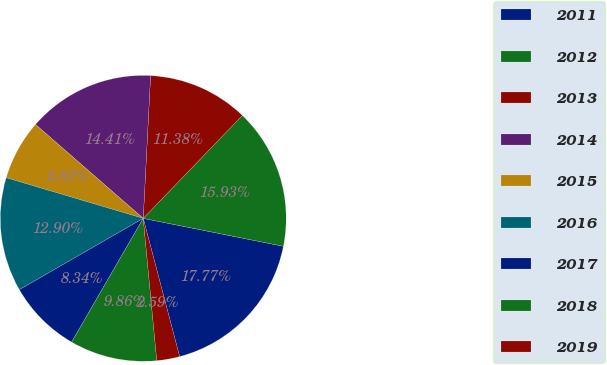Convert chart. <chart><loc_0><loc_0><loc_500><loc_500><pie_chart><fcel>2011<fcel>2012<fcel>2013<fcel>2014<fcel>2015<fcel>2016<fcel>2017<fcel>2018<fcel>2019<nl><fcel>17.77%<fcel>15.93%<fcel>11.38%<fcel>14.41%<fcel>6.82%<fcel>12.9%<fcel>8.34%<fcel>9.86%<fcel>2.59%<nl></chart> 